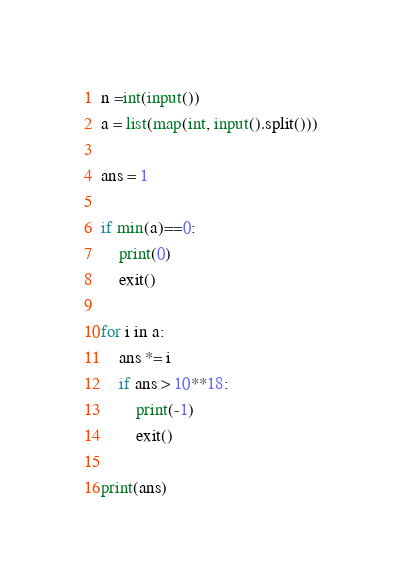Convert code to text. <code><loc_0><loc_0><loc_500><loc_500><_Python_>n =int(input())
a = list(map(int, input().split()))

ans = 1

if min(a)==0:
    print(0)
    exit()

for i in a:
    ans *= i
    if ans > 10**18:
        print(-1)
        exit()

print(ans)</code> 